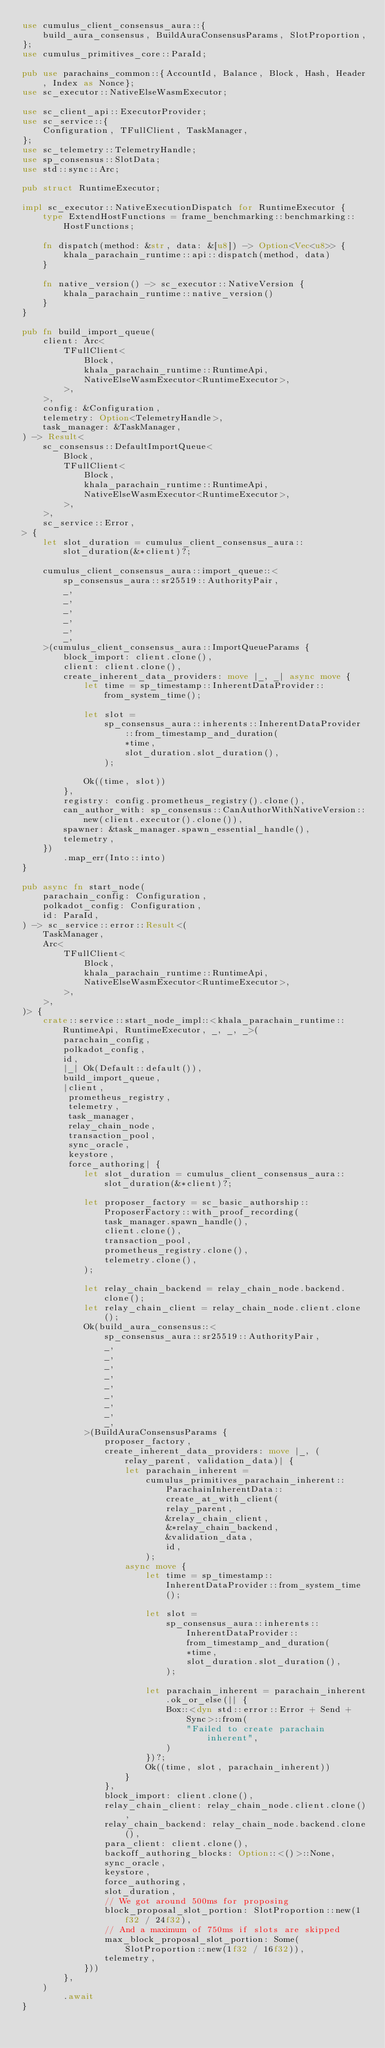<code> <loc_0><loc_0><loc_500><loc_500><_Rust_>use cumulus_client_consensus_aura::{
    build_aura_consensus, BuildAuraConsensusParams, SlotProportion,
};
use cumulus_primitives_core::ParaId;

pub use parachains_common::{AccountId, Balance, Block, Hash, Header, Index as Nonce};
use sc_executor::NativeElseWasmExecutor;

use sc_client_api::ExecutorProvider;
use sc_service::{
    Configuration, TFullClient, TaskManager,
};
use sc_telemetry::TelemetryHandle;
use sp_consensus::SlotData;
use std::sync::Arc;

pub struct RuntimeExecutor;

impl sc_executor::NativeExecutionDispatch for RuntimeExecutor {
    type ExtendHostFunctions = frame_benchmarking::benchmarking::HostFunctions;

    fn dispatch(method: &str, data: &[u8]) -> Option<Vec<u8>> {
        khala_parachain_runtime::api::dispatch(method, data)
    }

    fn native_version() -> sc_executor::NativeVersion {
        khala_parachain_runtime::native_version()
    }
}

pub fn build_import_queue(
    client: Arc<
        TFullClient<
            Block,
            khala_parachain_runtime::RuntimeApi,
            NativeElseWasmExecutor<RuntimeExecutor>,
        >,
    >,
    config: &Configuration,
    telemetry: Option<TelemetryHandle>,
    task_manager: &TaskManager,
) -> Result<
    sc_consensus::DefaultImportQueue<
        Block,
        TFullClient<
            Block,
            khala_parachain_runtime::RuntimeApi,
            NativeElseWasmExecutor<RuntimeExecutor>,
        >,
    >,
    sc_service::Error,
> {
    let slot_duration = cumulus_client_consensus_aura::slot_duration(&*client)?;

    cumulus_client_consensus_aura::import_queue::<
        sp_consensus_aura::sr25519::AuthorityPair,
        _,
        _,
        _,
        _,
        _,
        _,
    >(cumulus_client_consensus_aura::ImportQueueParams {
        block_import: client.clone(),
        client: client.clone(),
        create_inherent_data_providers: move |_, _| async move {
            let time = sp_timestamp::InherentDataProvider::from_system_time();

            let slot =
                sp_consensus_aura::inherents::InherentDataProvider::from_timestamp_and_duration(
                    *time,
                    slot_duration.slot_duration(),
                );

            Ok((time, slot))
        },
        registry: config.prometheus_registry().clone(),
        can_author_with: sp_consensus::CanAuthorWithNativeVersion::new(client.executor().clone()),
        spawner: &task_manager.spawn_essential_handle(),
        telemetry,
    })
        .map_err(Into::into)
}

pub async fn start_node(
    parachain_config: Configuration,
    polkadot_config: Configuration,
    id: ParaId,
) -> sc_service::error::Result<(
    TaskManager,
    Arc<
        TFullClient<
            Block,
            khala_parachain_runtime::RuntimeApi,
            NativeElseWasmExecutor<RuntimeExecutor>,
        >,
    >,
)> {
    crate::service::start_node_impl::<khala_parachain_runtime::RuntimeApi, RuntimeExecutor, _, _, _>(
        parachain_config,
        polkadot_config,
        id,
        |_| Ok(Default::default()),
        build_import_queue,
        |client,
         prometheus_registry,
         telemetry,
         task_manager,
         relay_chain_node,
         transaction_pool,
         sync_oracle,
         keystore,
         force_authoring| {
            let slot_duration = cumulus_client_consensus_aura::slot_duration(&*client)?;

            let proposer_factory = sc_basic_authorship::ProposerFactory::with_proof_recording(
                task_manager.spawn_handle(),
                client.clone(),
                transaction_pool,
                prometheus_registry.clone(),
                telemetry.clone(),
            );

            let relay_chain_backend = relay_chain_node.backend.clone();
            let relay_chain_client = relay_chain_node.client.clone();
            Ok(build_aura_consensus::<
                sp_consensus_aura::sr25519::AuthorityPair,
                _,
                _,
                _,
                _,
                _,
                _,
                _,
                _,
                _,
            >(BuildAuraConsensusParams {
                proposer_factory,
                create_inherent_data_providers: move |_, (relay_parent, validation_data)| {
                    let parachain_inherent =
                        cumulus_primitives_parachain_inherent::ParachainInherentData::create_at_with_client(
                            relay_parent,
                            &relay_chain_client,
                            &*relay_chain_backend,
                            &validation_data,
                            id,
                        );
                    async move {
                        let time = sp_timestamp::InherentDataProvider::from_system_time();

                        let slot =
                            sp_consensus_aura::inherents::InherentDataProvider::from_timestamp_and_duration(
                                *time,
                                slot_duration.slot_duration(),
                            );

                        let parachain_inherent = parachain_inherent.ok_or_else(|| {
                            Box::<dyn std::error::Error + Send + Sync>::from(
                                "Failed to create parachain inherent",
                            )
                        })?;
                        Ok((time, slot, parachain_inherent))
                    }
                },
                block_import: client.clone(),
                relay_chain_client: relay_chain_node.client.clone(),
                relay_chain_backend: relay_chain_node.backend.clone(),
                para_client: client.clone(),
                backoff_authoring_blocks: Option::<()>::None,
                sync_oracle,
                keystore,
                force_authoring,
                slot_duration,
                // We got around 500ms for proposing
                block_proposal_slot_portion: SlotProportion::new(1f32 / 24f32),
                // And a maximum of 750ms if slots are skipped
                max_block_proposal_slot_portion: Some(SlotProportion::new(1f32 / 16f32)),
                telemetry,
            }))
        },
    )
        .await
}
</code> 